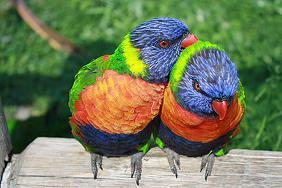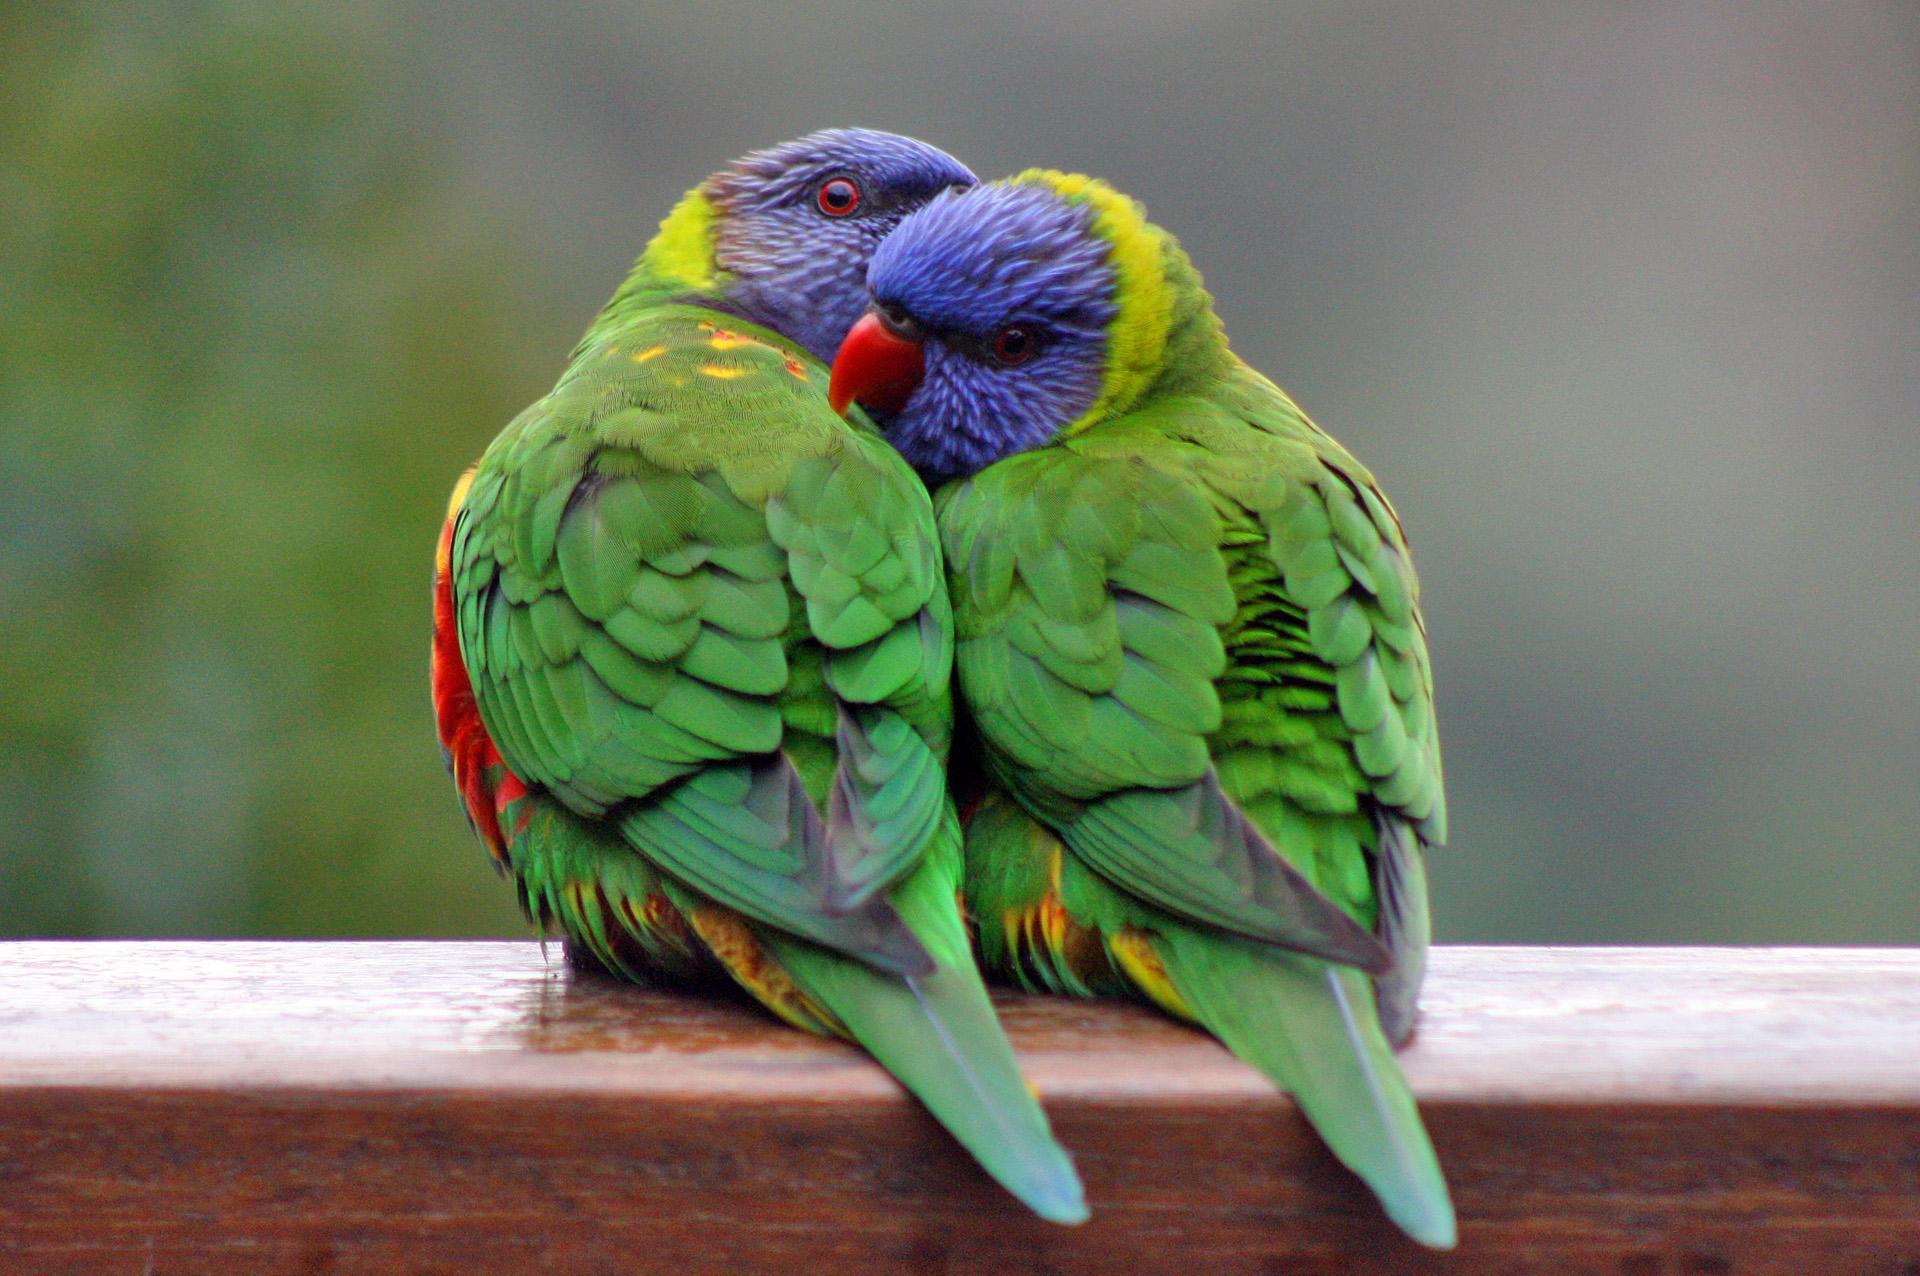The first image is the image on the left, the second image is the image on the right. Examine the images to the left and right. Is the description "A person's hand is visible offering a clear plastic cup to one or more colorful birds to feed fro" accurate? Answer yes or no. No. The first image is the image on the left, the second image is the image on the right. Analyze the images presented: Is the assertion "In one image, a hand is holding a plastic cup out for a parrot." valid? Answer yes or no. No. 